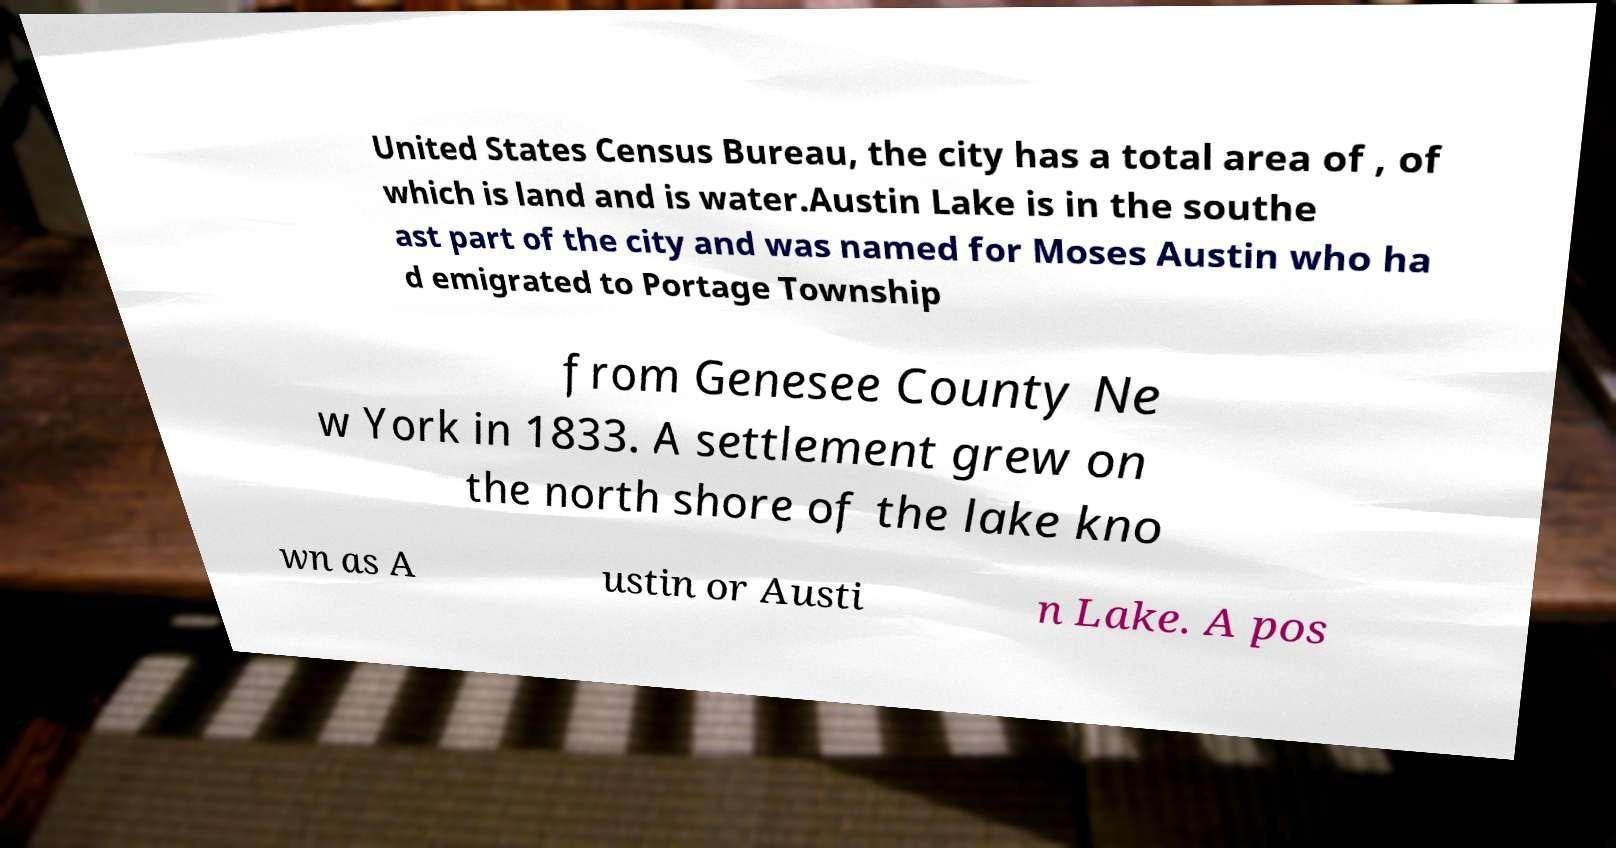I need the written content from this picture converted into text. Can you do that? United States Census Bureau, the city has a total area of , of which is land and is water.Austin Lake is in the southe ast part of the city and was named for Moses Austin who ha d emigrated to Portage Township from Genesee County Ne w York in 1833. A settlement grew on the north shore of the lake kno wn as A ustin or Austi n Lake. A pos 